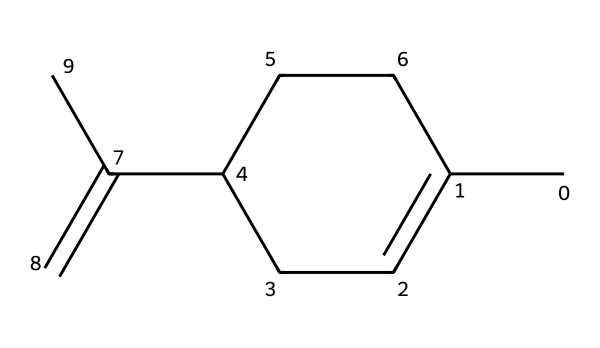What is the molecular formula of limonene? To determine the molecular formula from the SMILES representation, we need to count the number of each type of atom present. The SMILES shows 10 carbon atoms (C) and 16 hydrogen atoms (H), which gives us the formula C10H16.
Answer: C10H16 How many double bonds are present in limonene? In the SMILES representation, we see the 'C(=C)' notation, which indicates one double bond. Additionally, the structure contains one more double bond between the carbon atoms, leading to a total of two double bonds in the entire molecule.
Answer: 2 What functional groups are identified in limonene? By analyzing the structure, limonene does not contain any functional groups typically associated with alcohols, ketones, or carboxylic acids. It primarily consists of a hydrocarbon framework typical of terpenes.
Answer: None What type of compound is limonene classified as? Limonene is a cyclic terpene, which is indicated by its ring structure in the SMILES. The presence of multiple carbon-carbon bonds and the configuration help to categorize it as a terpene, specifically a monoterpene due to containing 10 carbon atoms.
Answer: Terpene How does the structure of limonene contribute to its citrus scent? The specific arrangement of carbon atoms and the presence of double bonds in the structure contribute to its volatility and the way it interacts with olfactory receptors, leading to its characteristic citrus aroma. The unique structural properties of the molecule make it a common component in the aroma of citrus fruits.
Answer: Structural arrangement Which cooking applications would typically use limonene? Limonene is commonly used in flavoring and fragrance applications, specifically in the preparation of desserts, beverages, and sometimes in savory dishes to enhance flavor profiles. Its presence in citrus oils makes it ideal for these applications.
Answer: Flavoring and fragrance 